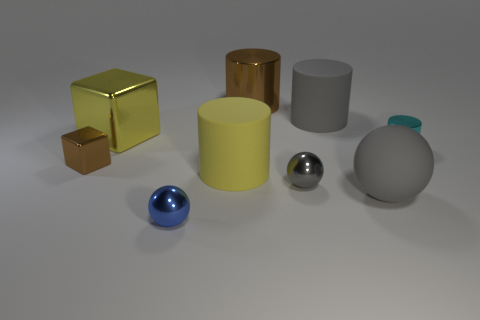Do the big yellow thing left of the yellow matte object and the large brown thing have the same shape?
Provide a short and direct response. No. What is the material of the large cylinder that is in front of the tiny cyan thing?
Offer a very short reply. Rubber. The brown thing behind the large rubber cylinder that is right of the gray shiny thing is what shape?
Your answer should be very brief. Cylinder. Do the big brown thing and the gray matte thing in front of the cyan cylinder have the same shape?
Provide a short and direct response. No. How many brown objects are in front of the large brown object that is behind the yellow block?
Your response must be concise. 1. What is the material of the tiny gray thing that is the same shape as the blue metallic thing?
Make the answer very short. Metal. What number of yellow things are either big matte cylinders or small balls?
Your response must be concise. 1. Are there any other things of the same color as the tiny cylinder?
Your answer should be compact. No. There is a shiny cube in front of the yellow object on the left side of the tiny blue thing; what color is it?
Your answer should be very brief. Brown. Is the number of big metal things in front of the tiny gray object less than the number of tiny cyan shiny cylinders in front of the big rubber sphere?
Give a very brief answer. No. 